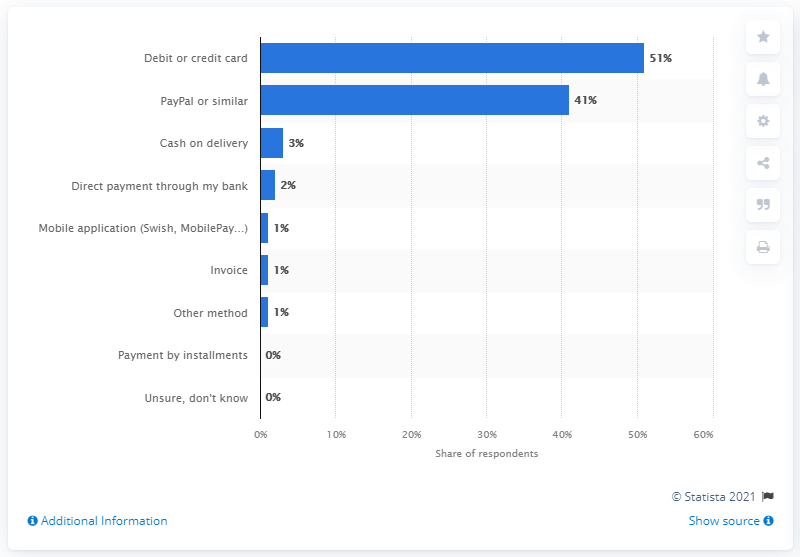Identify some key points in this picture. The most and least popular modes of payment differ in terms of their popularity and acceptance among consumers and merchants. According to the given data, debit cards are the most popular method of payment. 